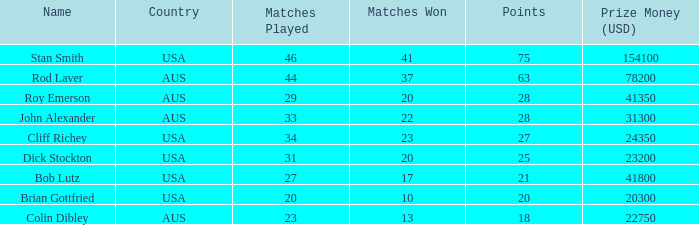Would you mind parsing the complete table? {'header': ['Name', 'Country', 'Matches Played', 'Matches Won', 'Points', 'Prize Money (USD)'], 'rows': [['Stan Smith', 'USA', '46', '41', '75', '154100'], ['Rod Laver', 'AUS', '44', '37', '63', '78200'], ['Roy Emerson', 'AUS', '29', '20', '28', '41350'], ['John Alexander', 'AUS', '33', '22', '28', '31300'], ['Cliff Richey', 'USA', '34', '23', '27', '24350'], ['Dick Stockton', 'USA', '31', '20', '25', '23200'], ['Bob Lutz', 'USA', '27', '17', '21', '41800'], ['Brian Gottfried', 'USA', '20', '10', '20', '20300'], ['Colin Dibley', 'AUS', '23', '13', '18', '22750']]} In how many games did colin dibley achieve victory? 13.0. 